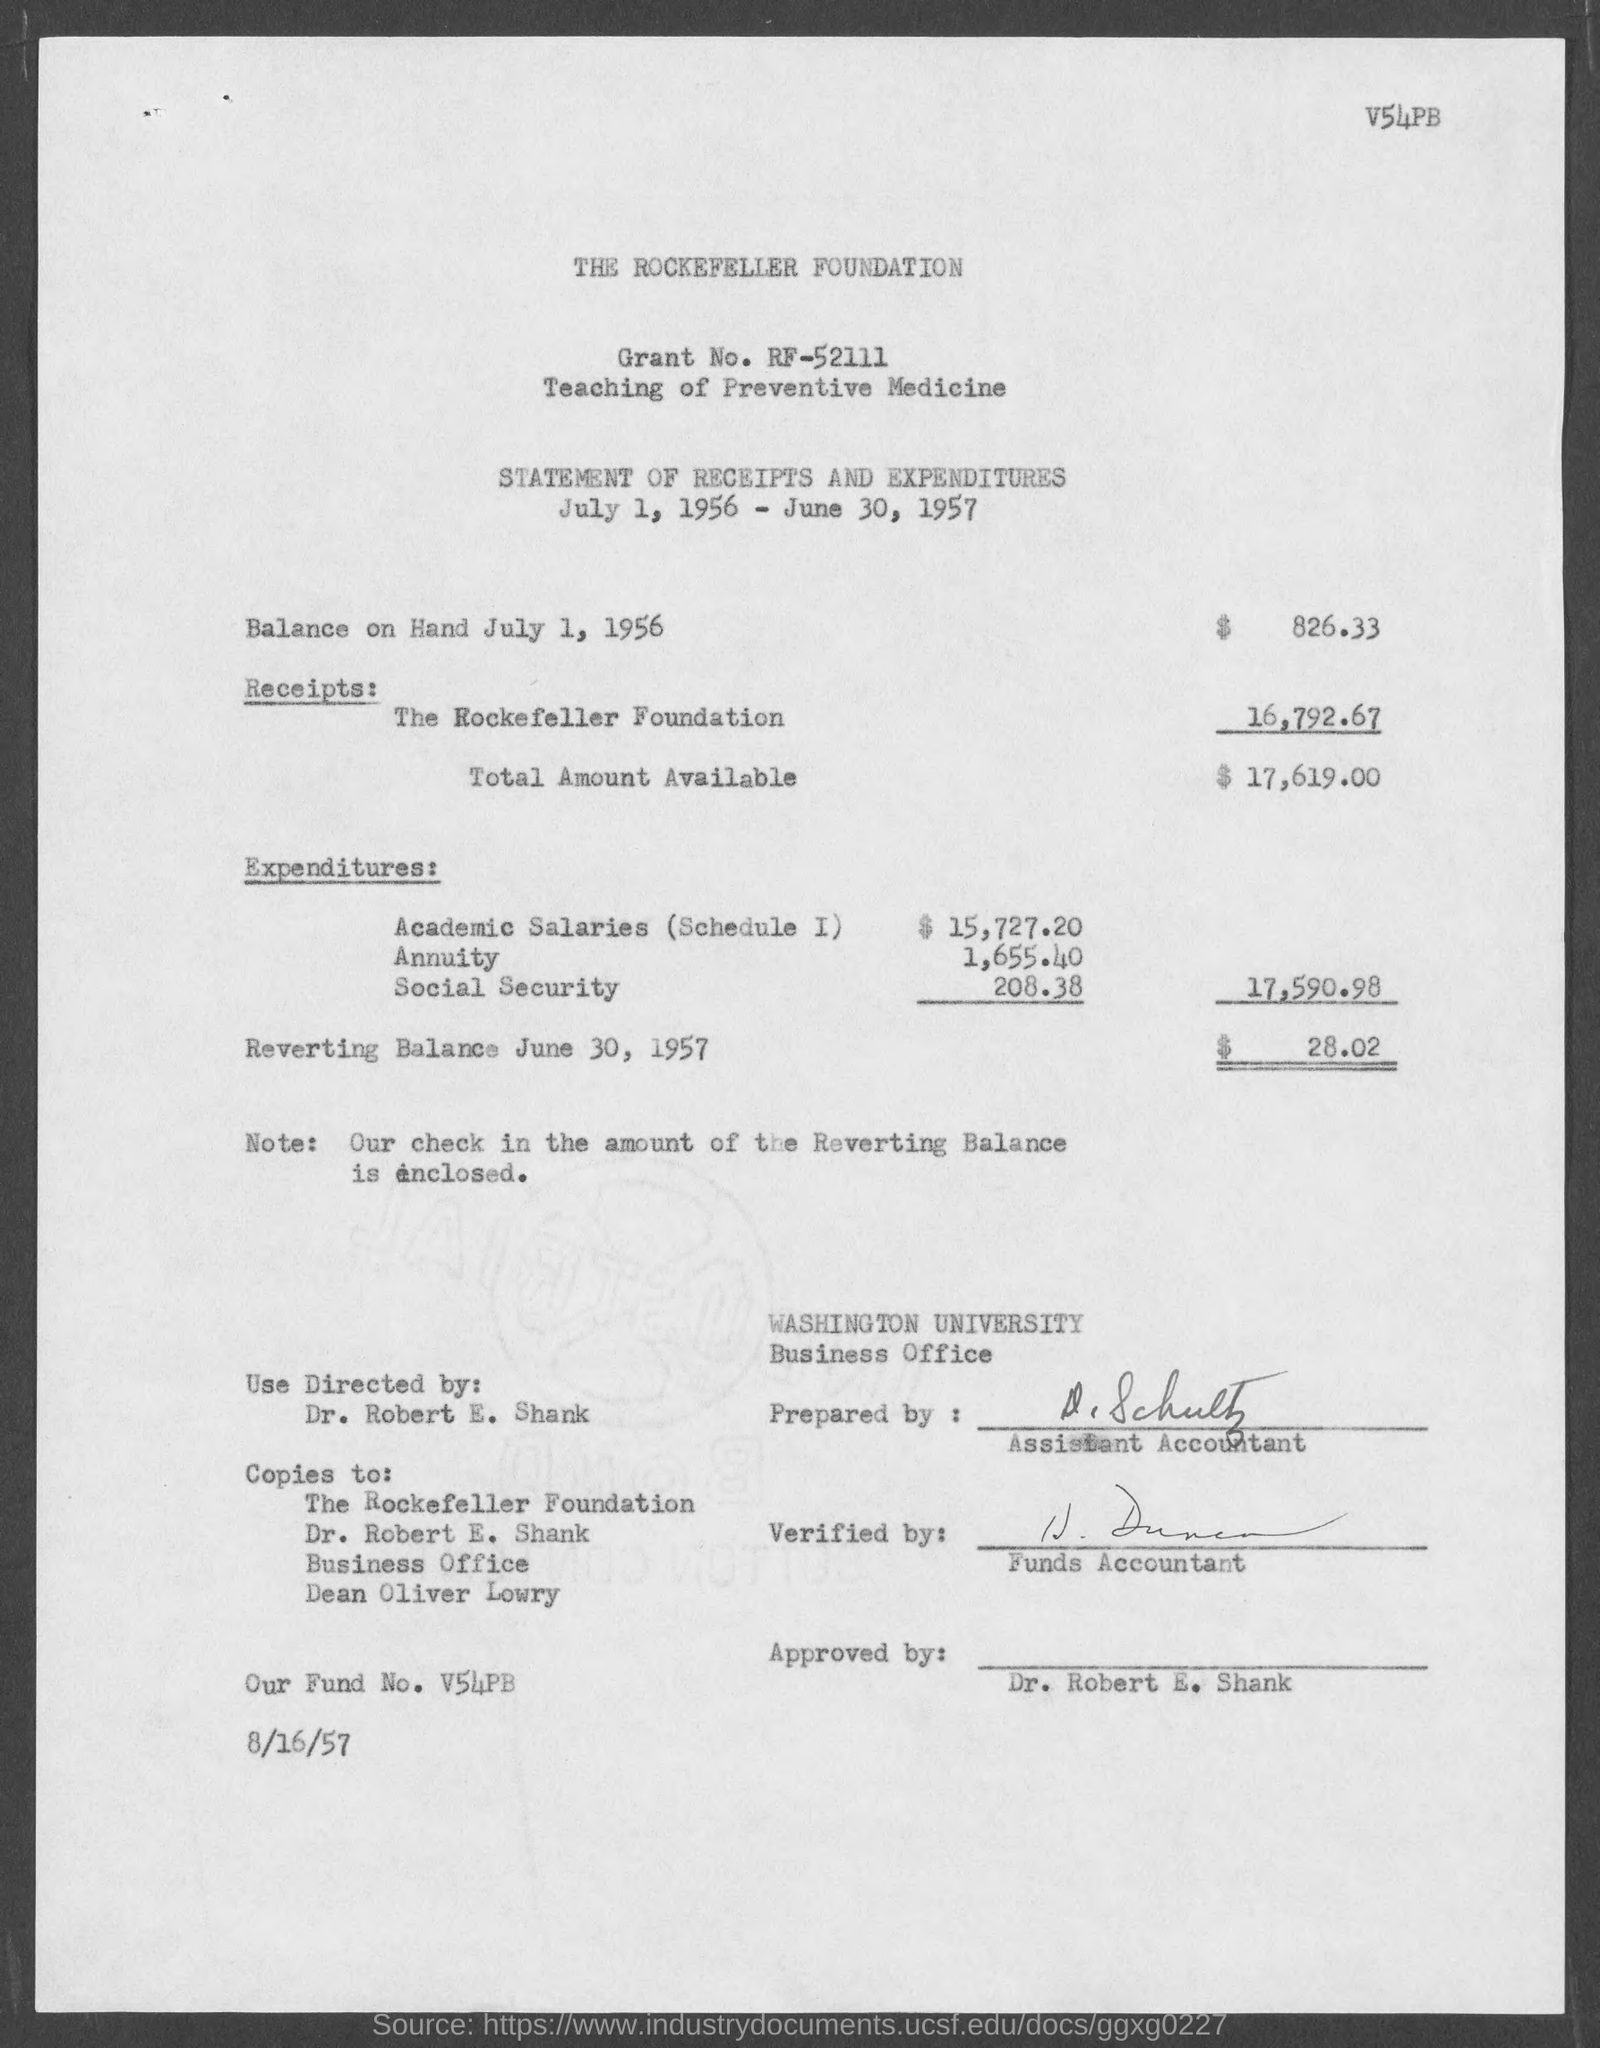What is the grant no. ?
Provide a short and direct response. RF-52111. What is the fund no.?
Your answer should be very brief. V54pb. What is the total amount available ?
Your answer should be very brief. $ 17,619.00. What is the balance on hand july 1, 1956?
Offer a terse response. $ 826.33. 